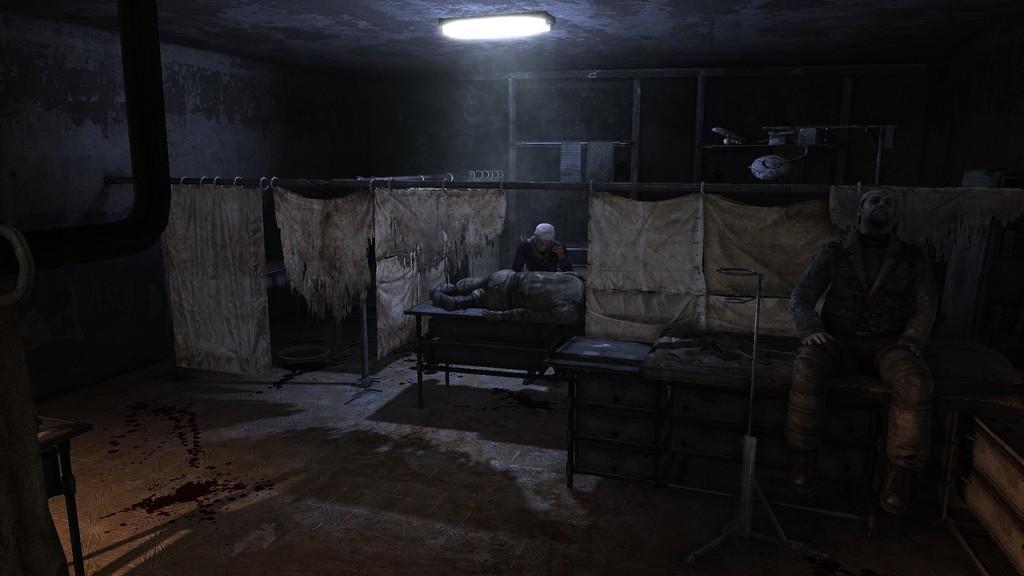Please provide a concise description of this image. On the right there is a man who is wearing army uniform and he is sitting on the table. Here we can see another man who is lying on the table, beside him we can see person who is standing near to him. On the top there is a light. Here we can see poles and white cloth hanging on it. 